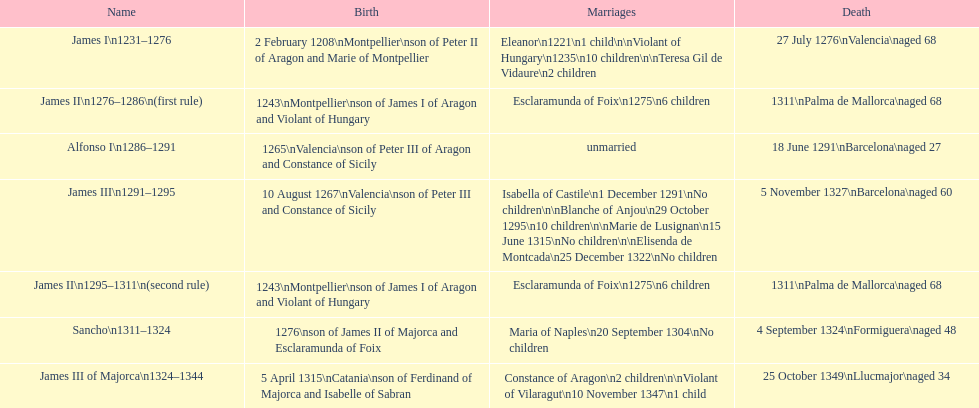What name is above james iii and below james ii? Alfonso I. 